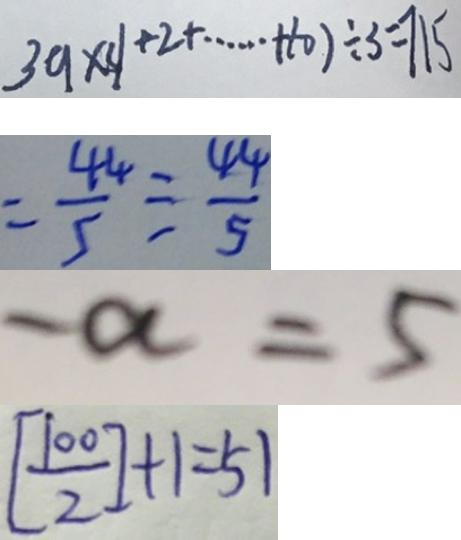<formula> <loc_0><loc_0><loc_500><loc_500>3 9 \times ( 1 + 2 + \cdots + 1 0 ) \div 3 = 7 1 5 
 = \frac { 4 4 } { 5 } \div \frac { 4 4 } { 5 } 
 - a = 5 
 [ \frac { 1 0 0 } { 2 } ] + 1 = 5 1</formula> 